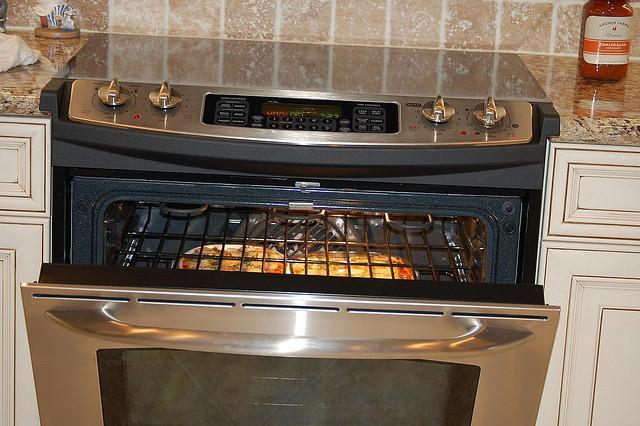How many sheep are here?
Give a very brief answer. 0. 